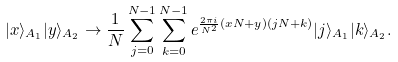Convert formula to latex. <formula><loc_0><loc_0><loc_500><loc_500>| x \rangle _ { A _ { 1 } } | y \rangle _ { A _ { 2 } } \rightarrow \frac { 1 } { N } \sum _ { j = 0 } ^ { N - 1 } \sum _ { k = 0 } ^ { N - 1 } e ^ { \frac { 2 \pi i } { N ^ { 2 } } ( x N + y ) ( j N + k ) } | j \rangle _ { A _ { 1 } } | k \rangle _ { A _ { 2 } } .</formula> 